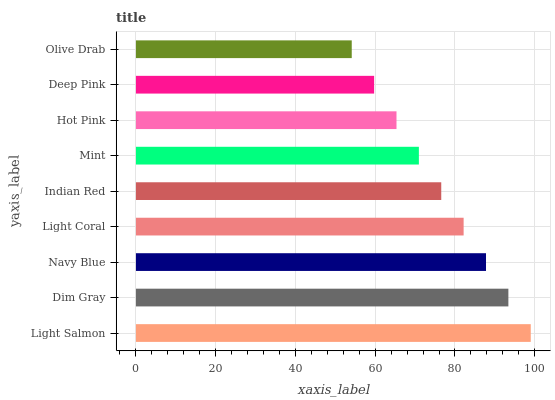Is Olive Drab the minimum?
Answer yes or no. Yes. Is Light Salmon the maximum?
Answer yes or no. Yes. Is Dim Gray the minimum?
Answer yes or no. No. Is Dim Gray the maximum?
Answer yes or no. No. Is Light Salmon greater than Dim Gray?
Answer yes or no. Yes. Is Dim Gray less than Light Salmon?
Answer yes or no. Yes. Is Dim Gray greater than Light Salmon?
Answer yes or no. No. Is Light Salmon less than Dim Gray?
Answer yes or no. No. Is Indian Red the high median?
Answer yes or no. Yes. Is Indian Red the low median?
Answer yes or no. Yes. Is Light Salmon the high median?
Answer yes or no. No. Is Olive Drab the low median?
Answer yes or no. No. 